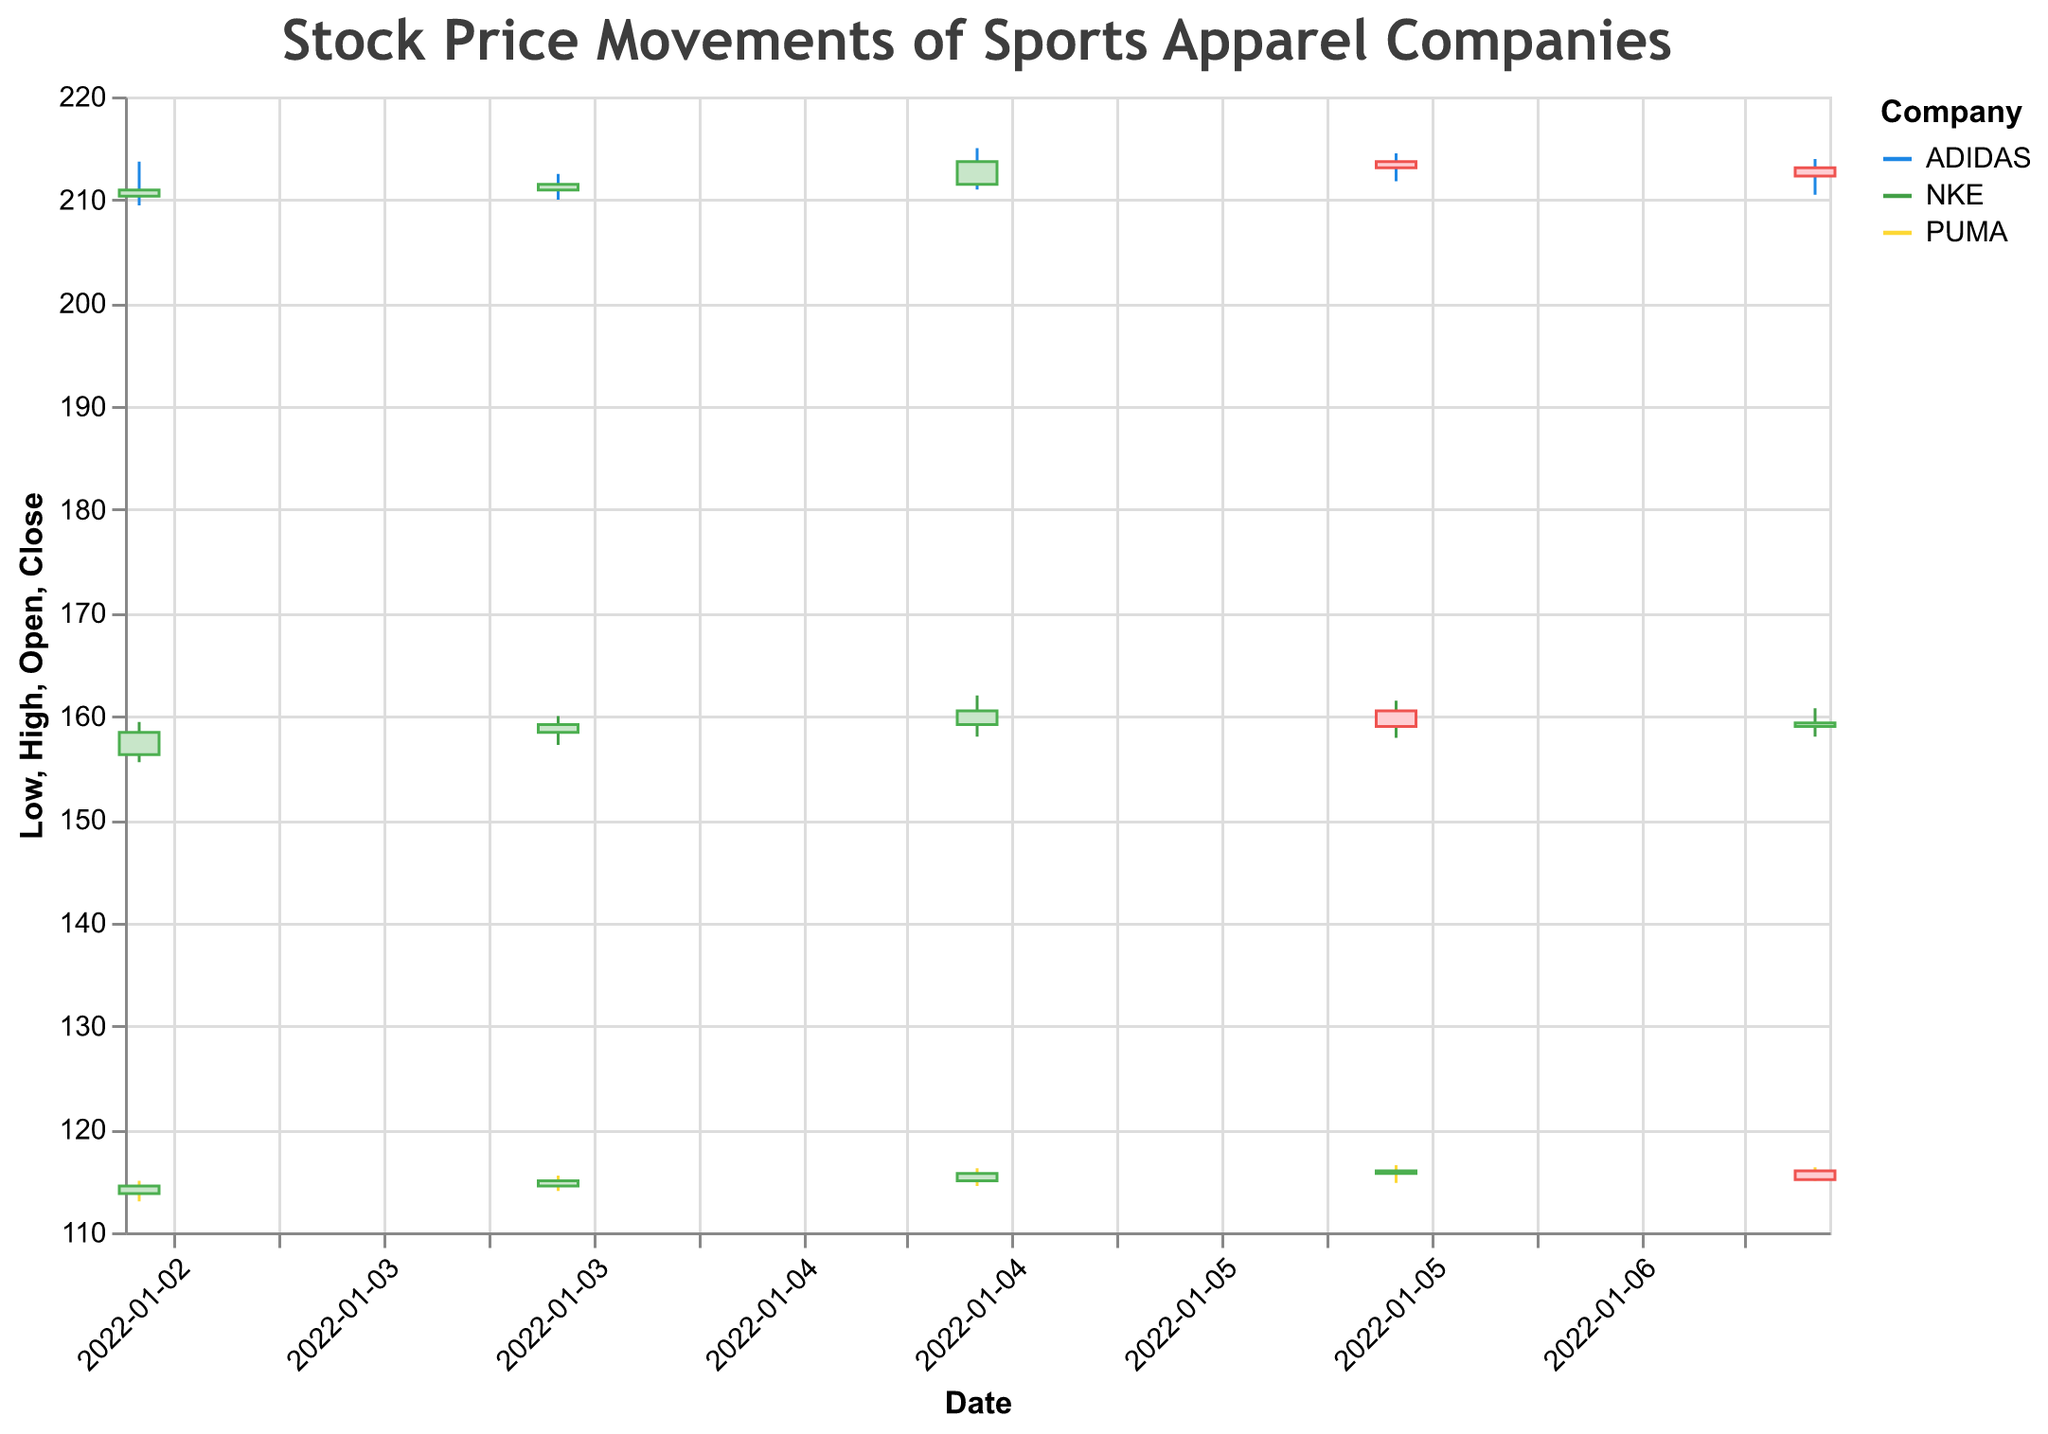What's the title of the chart? The title is usually located at the top of the chart and specifies what the figure is about. In this case, the title is "Stock Price Movements of Sports Apparel Companies".
Answer: Stock Price Movements of Sports Apparel Companies How many companies' stock prices are shown in the chart? The colors and legend indicate there are three different companies represented: Nike (NKE), Adidas, and Puma.
Answer: 3 Which company's stock had the highest single-day high price and what was that price? First, identify the highest 'High' value for each company. Nike's highest 'High' is 162.00 on 2022-01-05, Adidas's is 215.00 on 2022-01-05, and Puma's is 116.50 on 2022-01-06. Among these, Adidas has the highest value of 215.00.
Answer: Adidas, 215.00 On which date did Nike experience the highest trading volume, and what was that volume? Review the data for Nike's trading volume. Nike experienced the highest volume of 1,400,000 on 2022-01-05.
Answer: 2022-01-05, 1,400,000 What is the trend in Puma's closing prices over the given dates? By looking at the closing prices from 2022-01-03 to 2022-01-07 (114.50, 115.00, 115.70, 115.95, 115.10), it appears that Puma's closing prices initially increased, reaching a peak on 2022-01-06, then slightly decreased on the last day.
Answer: Initial increase, then slight decrease How did Adidas's closing price on January 4 compare to its opening price on the same day? The opening price for Adidas on January 4 is 210.95, and the closing price is 211.50. The closing price is slightly higher than the opening price.
Answer: Close price higher Which company had the smallest range between its high and low prices on January 6, and what was that range? Calculate the range by subtracting the low price from the high price for each company on January 6: Nike (3.60), Adidas (2.70), and Puma (1.70). Puma had the smallest range (116.50 - 114.80 = 1.70).
Answer: Puma, 1.70 What was the closing price trend for Nike over the given timeframe? Review Nike's closing prices from January 3 to January 7 (158.42, 159.19, 160.50, 159.00, 159.35). It was generally upward, with a small dip on January 6.
Answer: Generally upward, small dip on January 6 What was the average closing price of Adidas over the week? Add up Adidas's closing prices (210.95, 211.50, 213.70, 213.10, 212.30) and divide by 5. The sum is 1061.55, so the average is 1061.55 / 5 = 212.31.
Answer: 212.31 